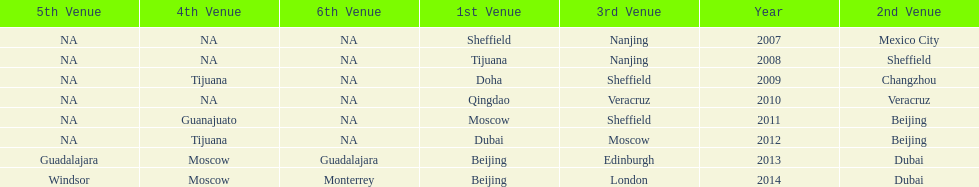Which two venue has no nations from 2007-2012 5th Venue, 6th Venue. 